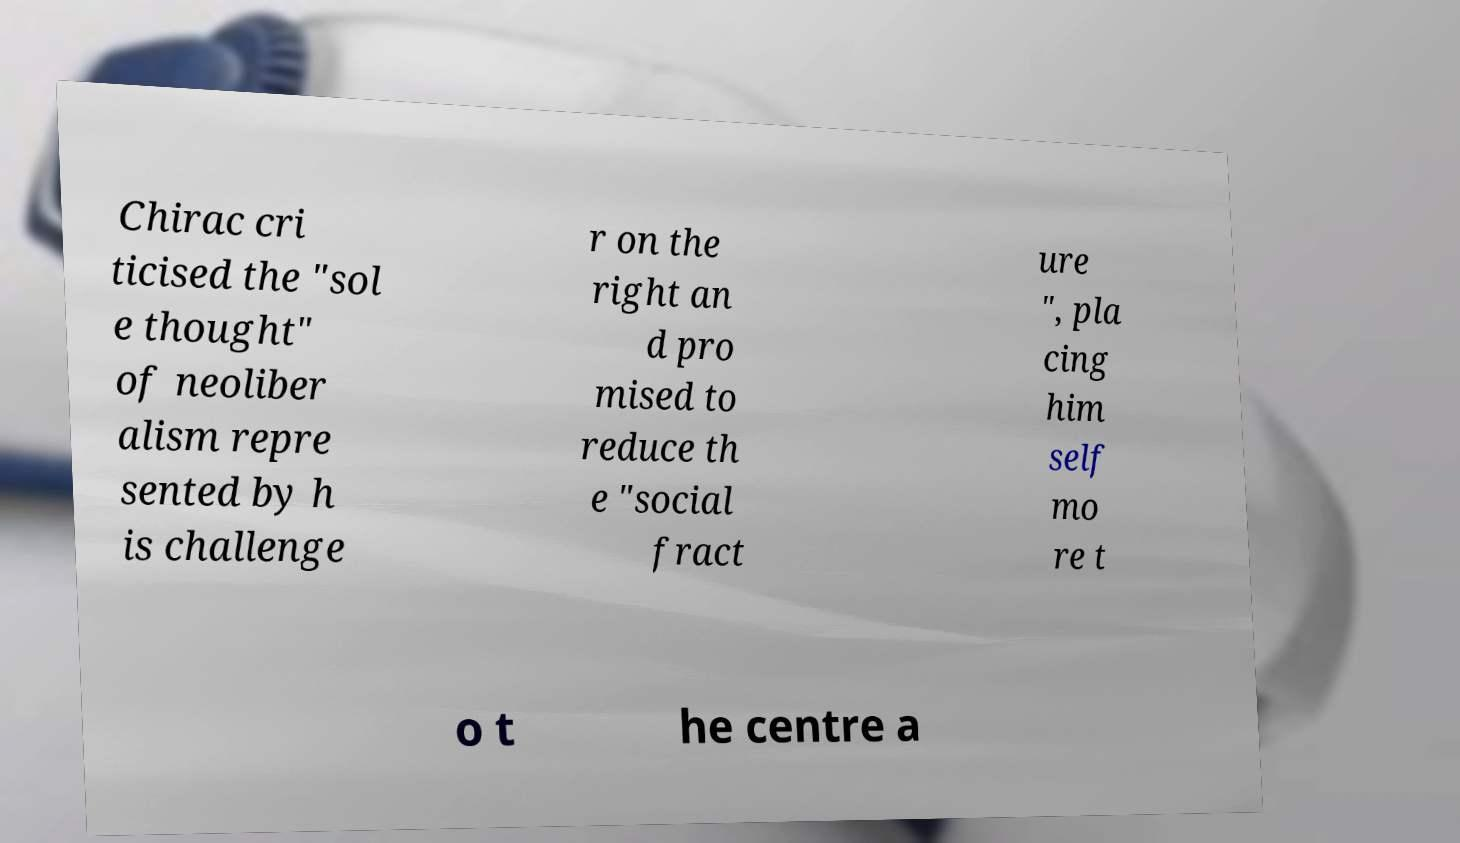Could you extract and type out the text from this image? Chirac cri ticised the "sol e thought" of neoliber alism repre sented by h is challenge r on the right an d pro mised to reduce th e "social fract ure ", pla cing him self mo re t o t he centre a 